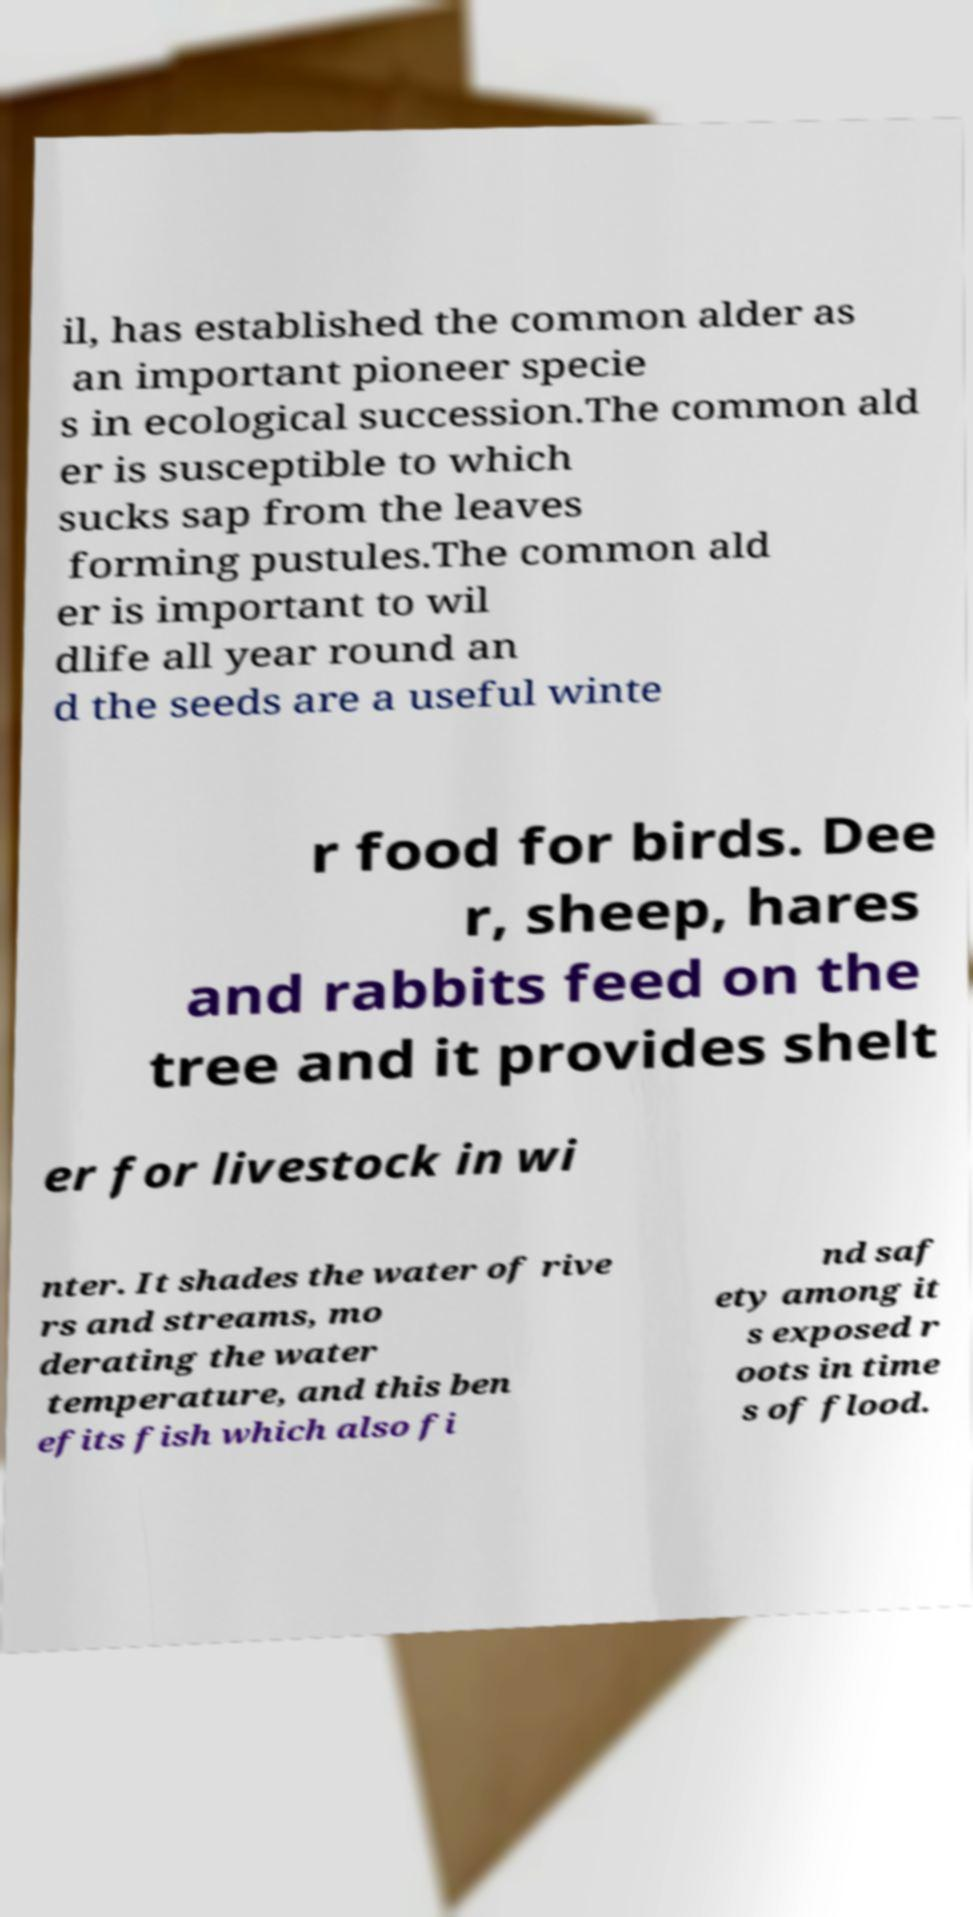Could you assist in decoding the text presented in this image and type it out clearly? il, has established the common alder as an important pioneer specie s in ecological succession.The common ald er is susceptible to which sucks sap from the leaves forming pustules.The common ald er is important to wil dlife all year round an d the seeds are a useful winte r food for birds. Dee r, sheep, hares and rabbits feed on the tree and it provides shelt er for livestock in wi nter. It shades the water of rive rs and streams, mo derating the water temperature, and this ben efits fish which also fi nd saf ety among it s exposed r oots in time s of flood. 